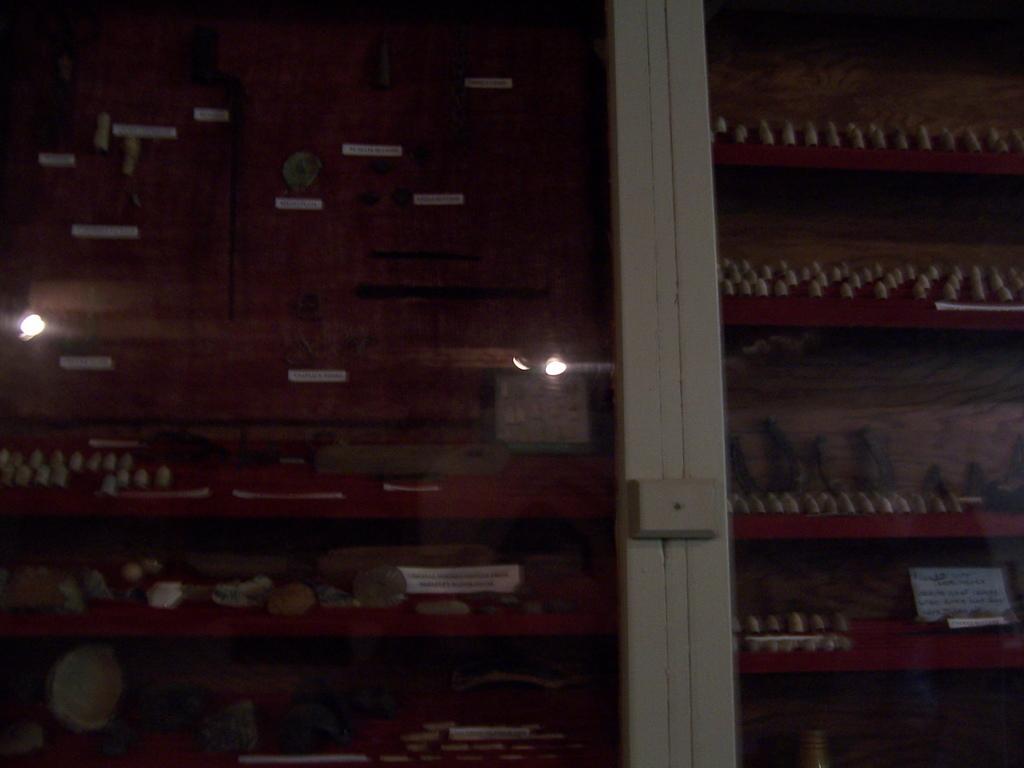Describe this image in one or two sentences. In this image I can see a rack , on the rack I can see a food item and I can see a light visible in front of the rack. 